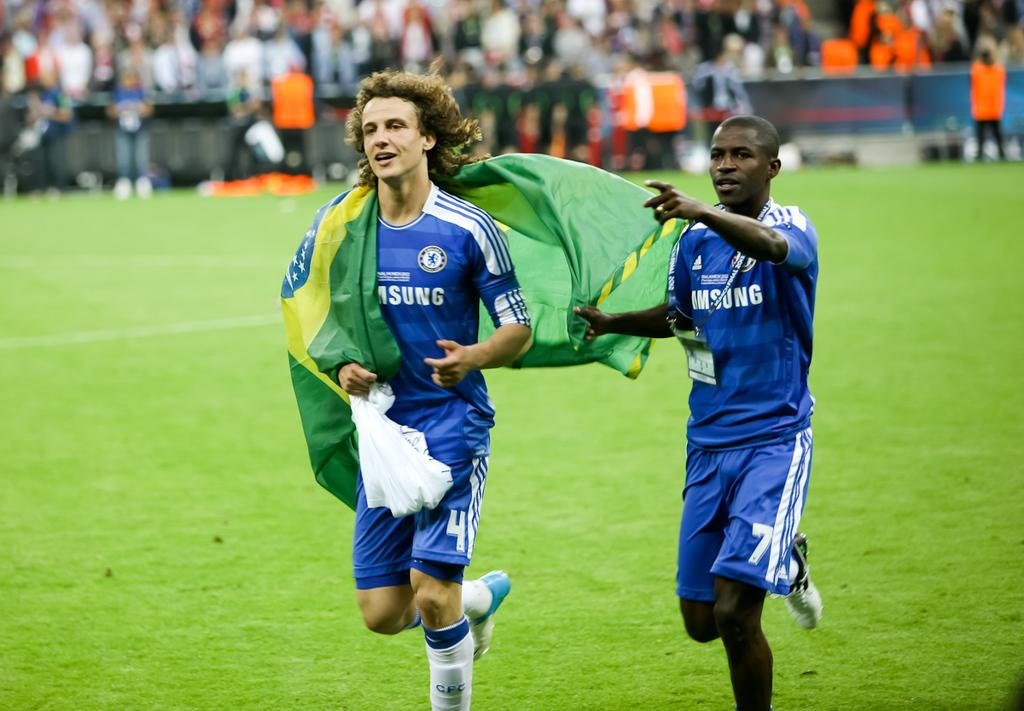<image>
Describe the image concisely. Player number 7 is draping a flag over player number 4's shoulders. 